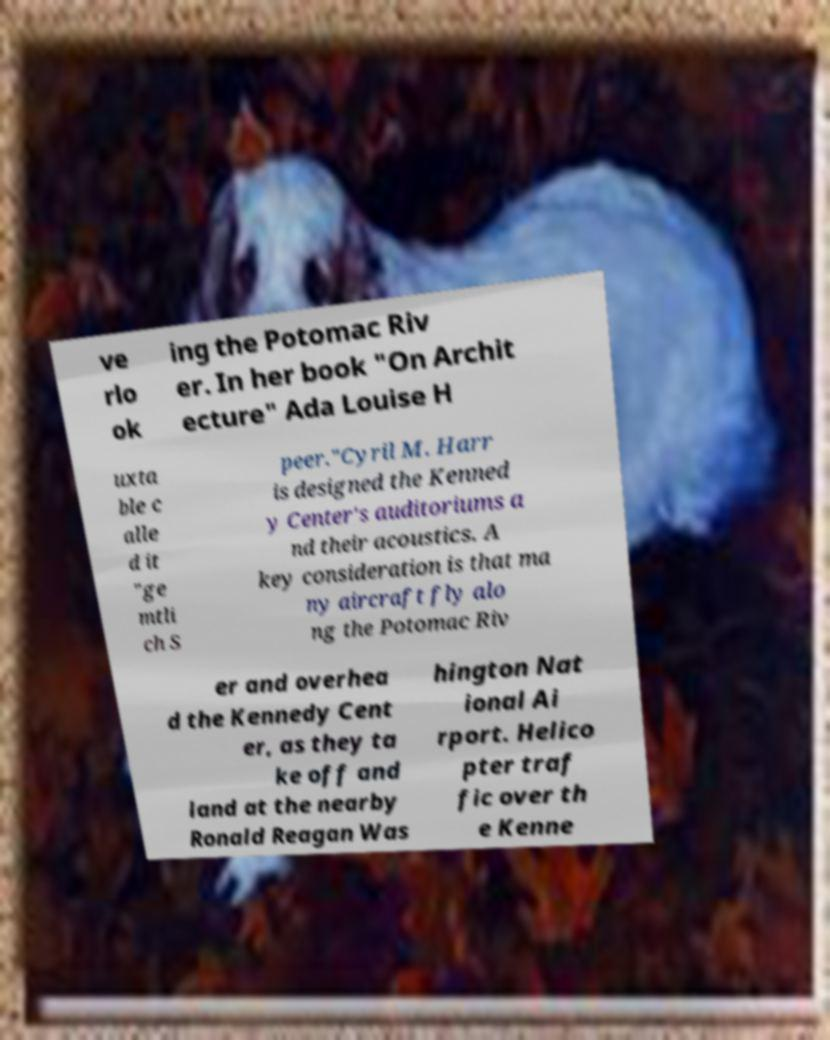What messages or text are displayed in this image? I need them in a readable, typed format. ve rlo ok ing the Potomac Riv er. In her book "On Archit ecture" Ada Louise H uxta ble c alle d it "ge mtli ch S peer."Cyril M. Harr is designed the Kenned y Center's auditoriums a nd their acoustics. A key consideration is that ma ny aircraft fly alo ng the Potomac Riv er and overhea d the Kennedy Cent er, as they ta ke off and land at the nearby Ronald Reagan Was hington Nat ional Ai rport. Helico pter traf fic over th e Kenne 